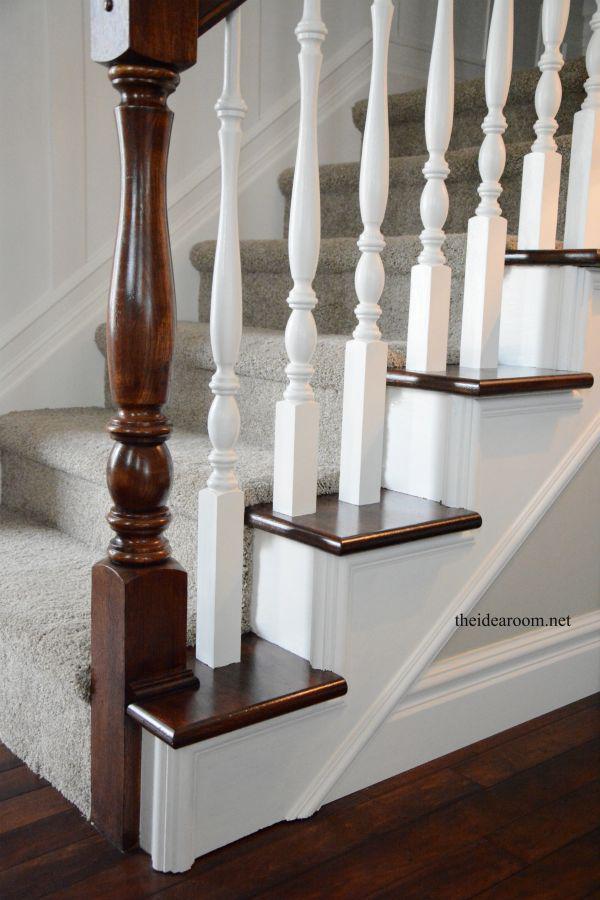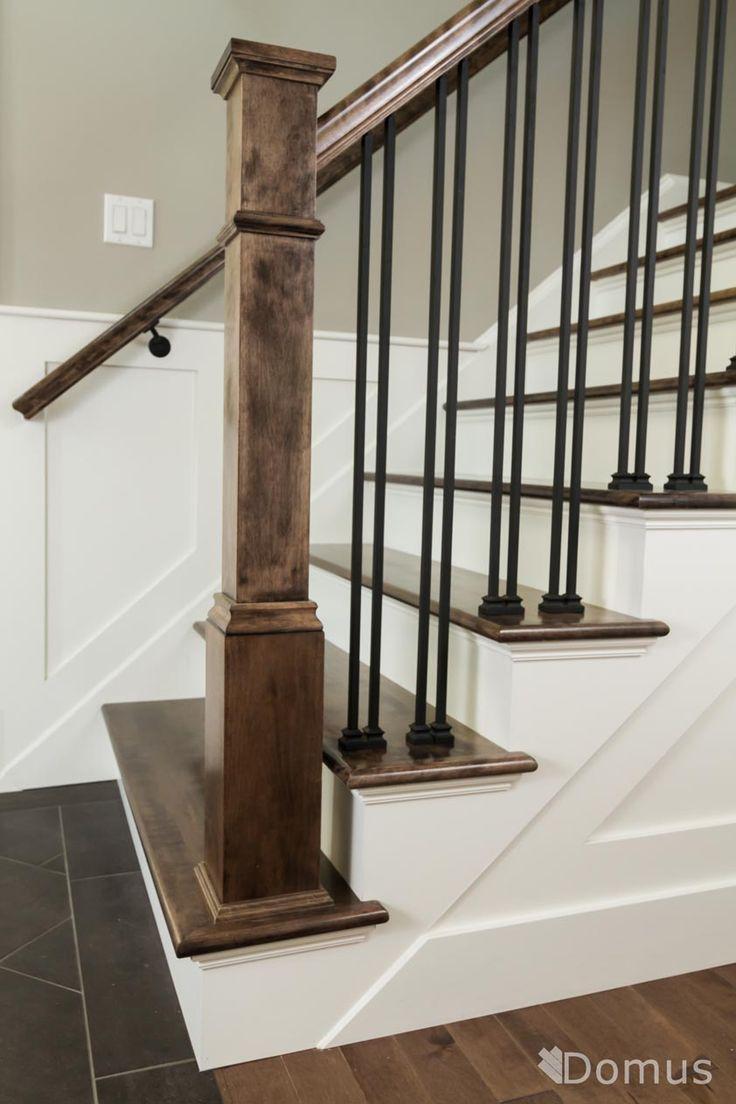The first image is the image on the left, the second image is the image on the right. Considering the images on both sides, is "One stairway changes direction." valid? Answer yes or no. No. 